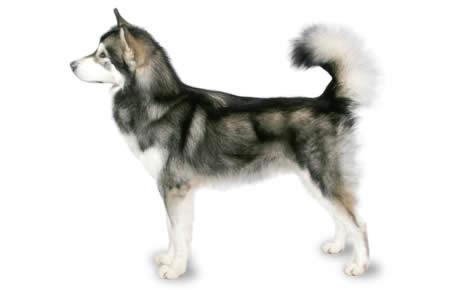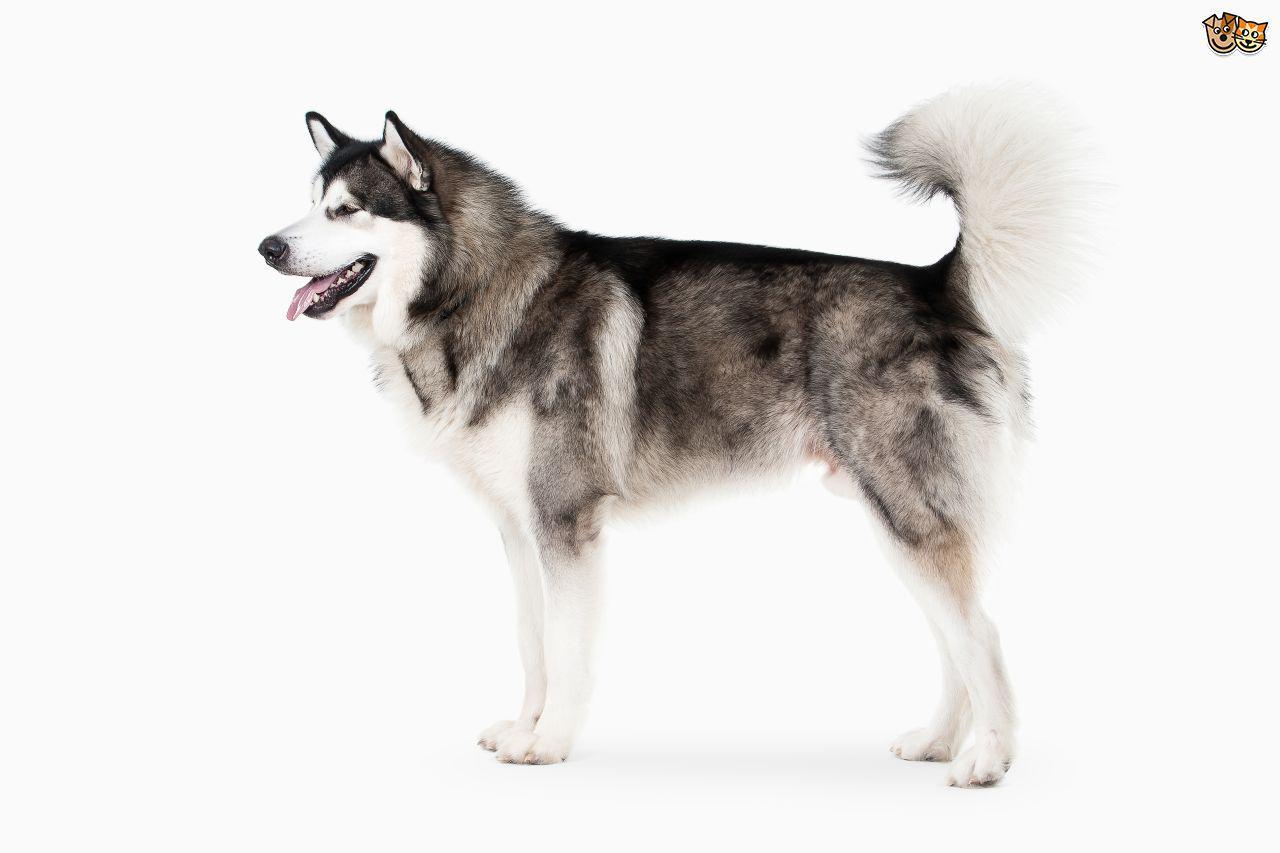The first image is the image on the left, the second image is the image on the right. For the images shown, is this caption "There are only two dogs, and both of them are showing their tongues." true? Answer yes or no. No. The first image is the image on the left, the second image is the image on the right. Given the left and right images, does the statement "All dogs are standing, and each image contains a dog with an upturned, curled tail." hold true? Answer yes or no. Yes. 